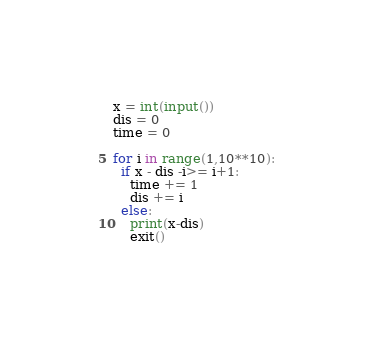<code> <loc_0><loc_0><loc_500><loc_500><_Python_>x = int(input())
dis = 0
time = 0

for i in range(1,10**10):
  if x - dis -i>= i+1:
    time += 1
    dis += i
  else:
    print(x-dis)
    exit()</code> 